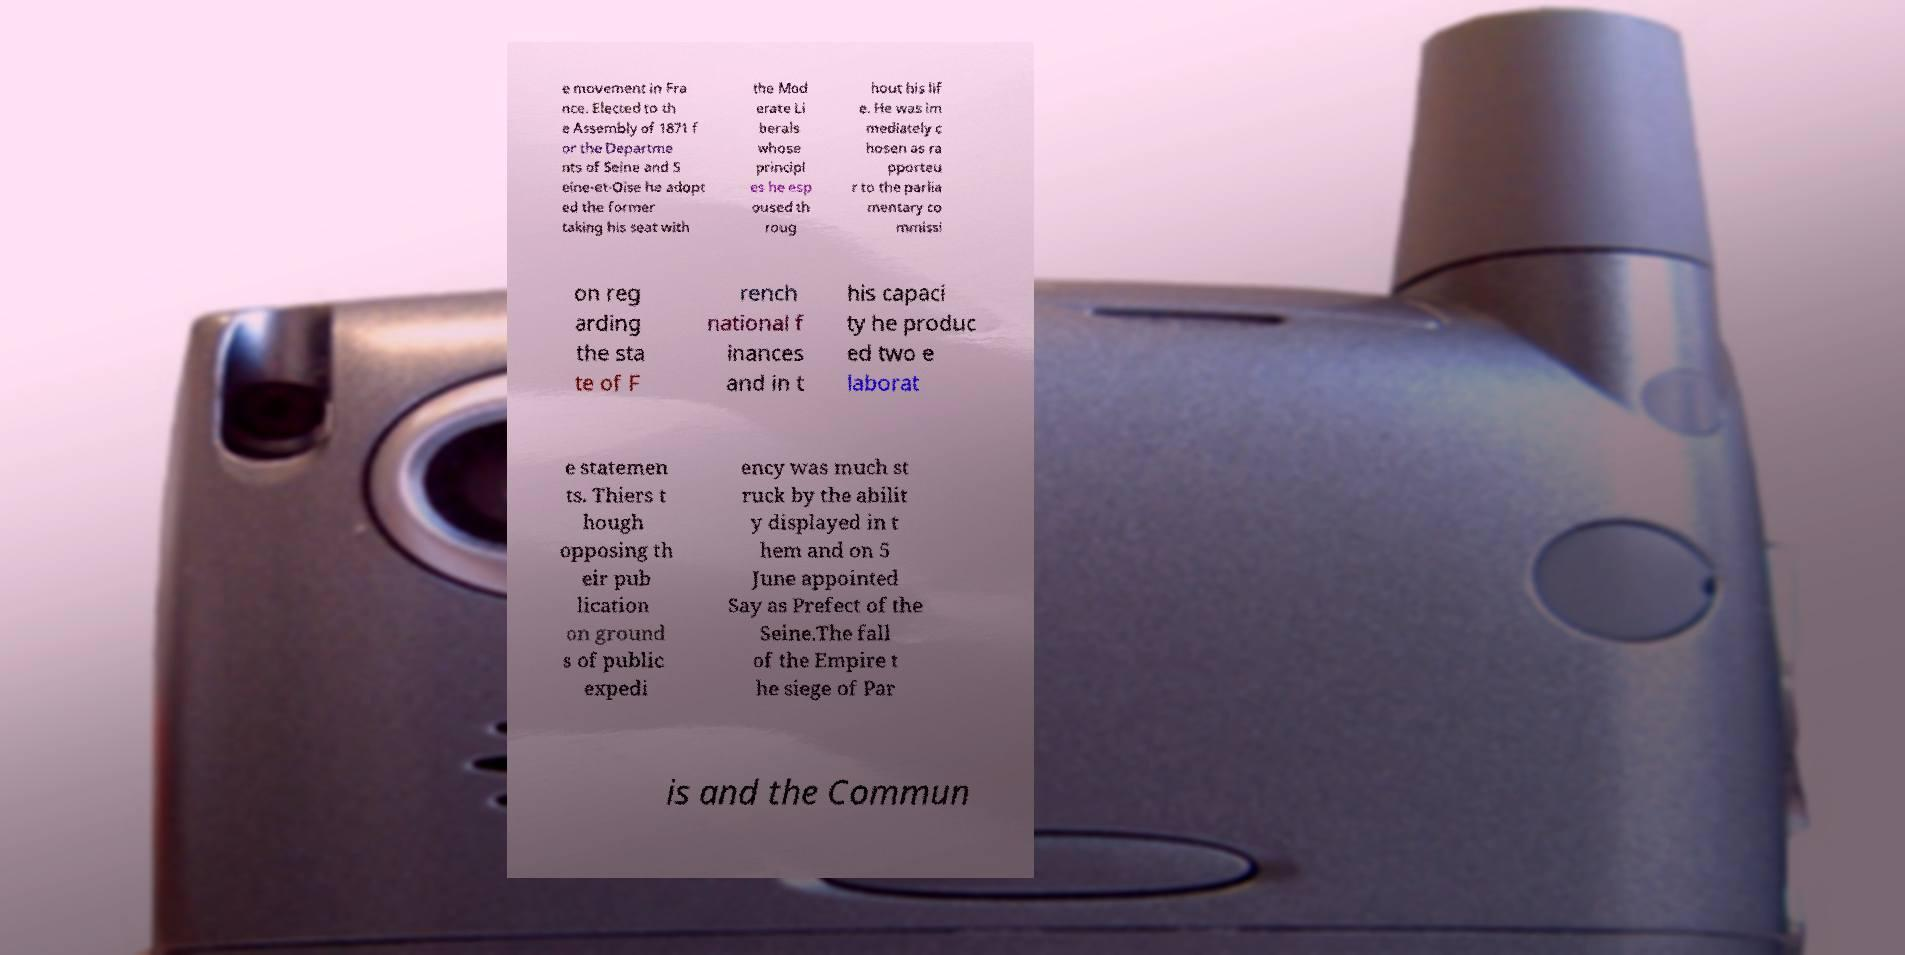Could you extract and type out the text from this image? e movement in Fra nce. Elected to th e Assembly of 1871 f or the Departme nts of Seine and S eine-et-Oise he adopt ed the former taking his seat with the Mod erate Li berals whose principl es he esp oused th roug hout his lif e. He was im mediately c hosen as ra pporteu r to the parlia mentary co mmissi on reg arding the sta te of F rench national f inances and in t his capaci ty he produc ed two e laborat e statemen ts. Thiers t hough opposing th eir pub lication on ground s of public expedi ency was much st ruck by the abilit y displayed in t hem and on 5 June appointed Say as Prefect of the Seine.The fall of the Empire t he siege of Par is and the Commun 